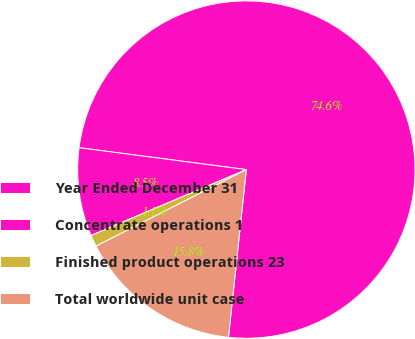<chart> <loc_0><loc_0><loc_500><loc_500><pie_chart><fcel>Year Ended December 31<fcel>Concentrate operations 1<fcel>Finished product operations 23<fcel>Total worldwide unit case<nl><fcel>74.61%<fcel>8.46%<fcel>1.11%<fcel>15.81%<nl></chart> 